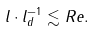<formula> <loc_0><loc_0><loc_500><loc_500>l \cdot l _ { d } ^ { - 1 } \lesssim R e .</formula> 